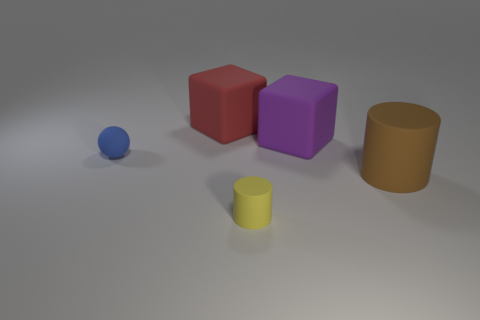Subtract all spheres. How many objects are left? 4 Add 5 big red rubber cubes. How many big red rubber cubes exist? 6 Add 1 brown cylinders. How many objects exist? 6 Subtract 1 purple cubes. How many objects are left? 4 Subtract all red blocks. Subtract all brown cylinders. How many blocks are left? 1 Subtract all yellow balls. How many purple cubes are left? 1 Subtract all big red blocks. Subtract all big purple matte things. How many objects are left? 3 Add 3 tiny blue objects. How many tiny blue objects are left? 4 